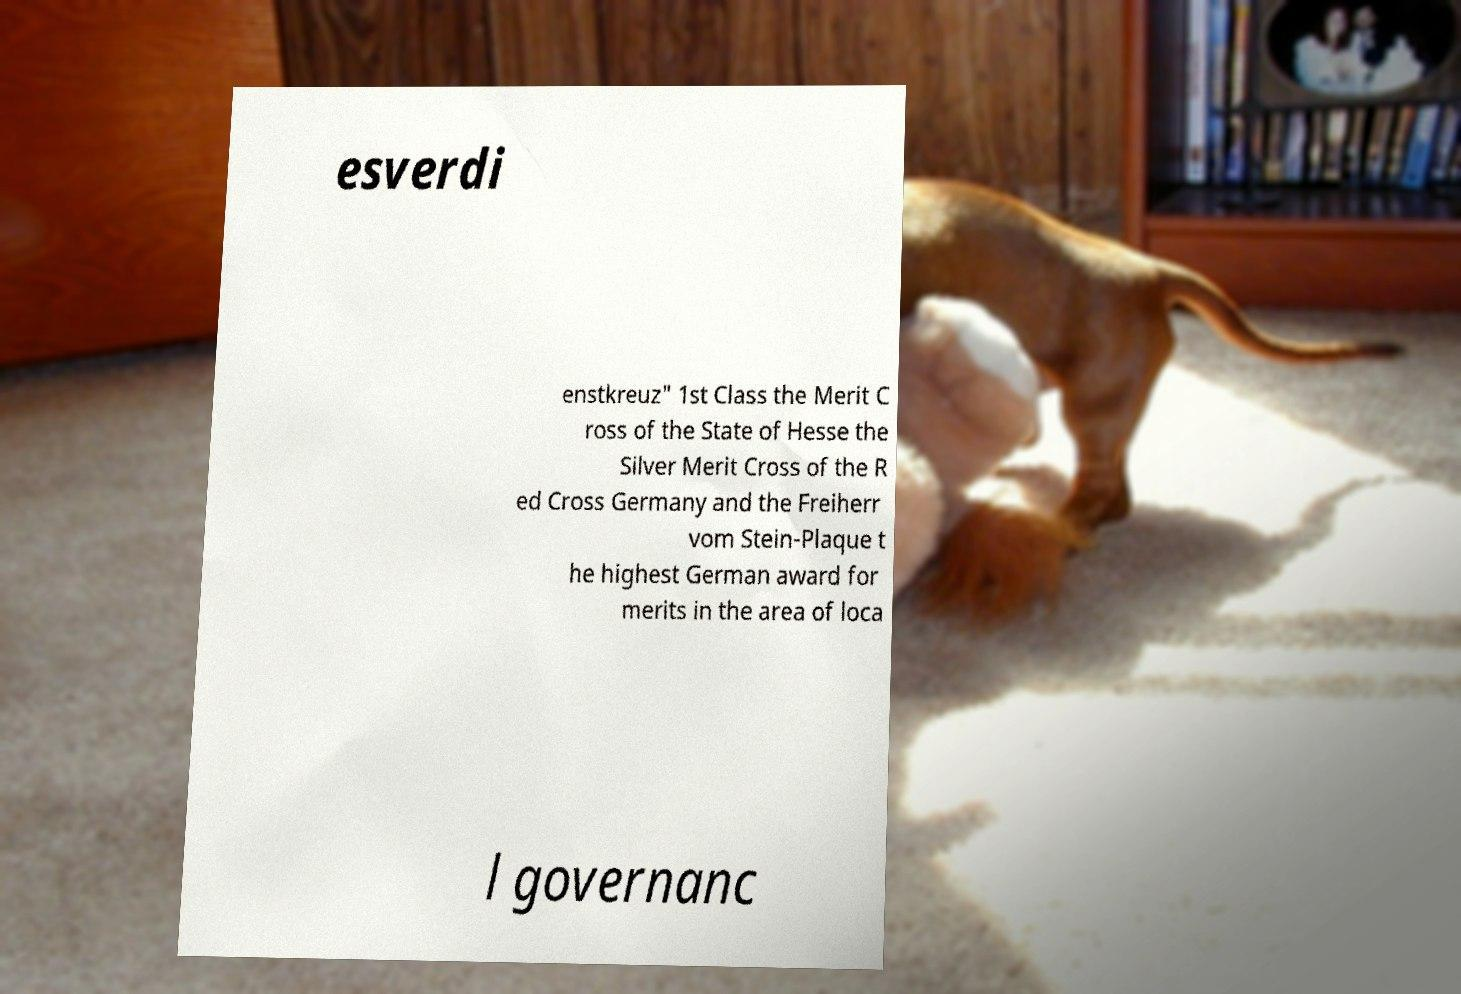Please read and relay the text visible in this image. What does it say? esverdi enstkreuz" 1st Class the Merit C ross of the State of Hesse the Silver Merit Cross of the R ed Cross Germany and the Freiherr vom Stein-Plaque t he highest German award for merits in the area of loca l governanc 